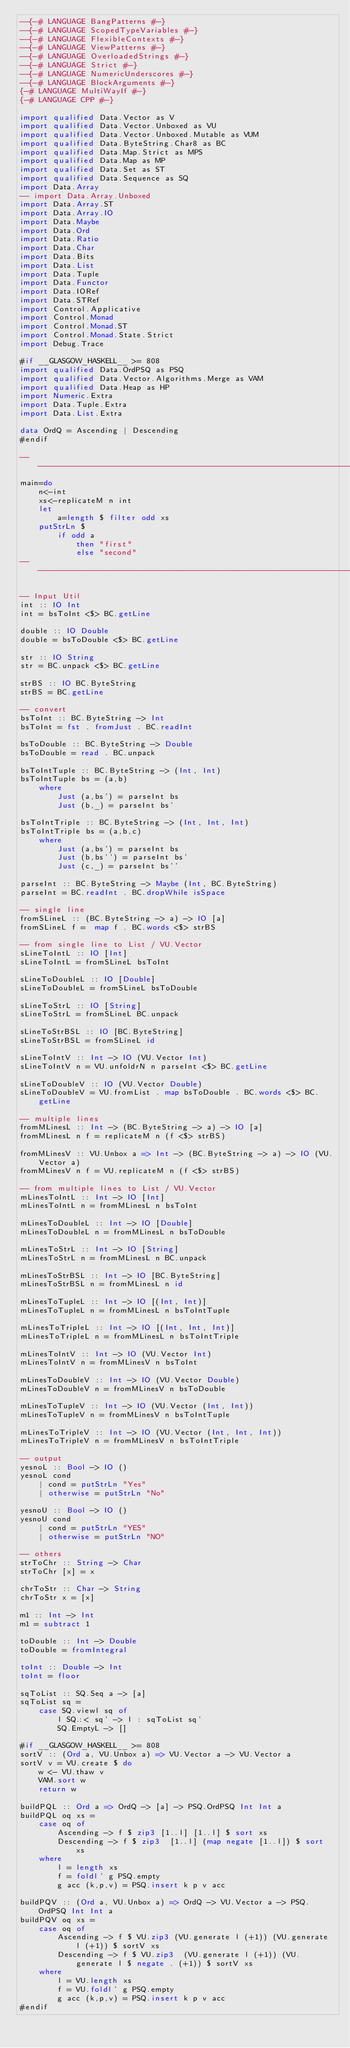<code> <loc_0><loc_0><loc_500><loc_500><_Haskell_>--{-# LANGUAGE BangPatterns #-}
--{-# LANGUAGE ScopedTypeVariables #-}
--{-# LANGUAGE FlexibleContexts #-}
--{-# LANGUAGE ViewPatterns #-}
--{-# LANGUAGE OverloadedStrings #-}
--{-# LANGUAGE Strict #-}
--{-# LANGUAGE NumericUnderscores #-}
--{-# LANGUAGE BlockArguments #-}
{-# LANGUAGE MultiWayIf #-}
{-# LANGUAGE CPP #-}

import qualified Data.Vector as V
import qualified Data.Vector.Unboxed as VU
import qualified Data.Vector.Unboxed.Mutable as VUM
import qualified Data.ByteString.Char8 as BC
import qualified Data.Map.Strict as MPS
import qualified Data.Map as MP
import qualified Data.Set as ST
import qualified Data.Sequence as SQ
import Data.Array
-- import Data.Array.Unboxed
import Data.Array.ST
import Data.Array.IO
import Data.Maybe
import Data.Ord
import Data.Ratio
import Data.Char
import Data.Bits
import Data.List
import Data.Tuple
import Data.Functor
import Data.IORef
import Data.STRef
import Control.Applicative
import Control.Monad
import Control.Monad.ST
import Control.Monad.State.Strict
import Debug.Trace

#if __GLASGOW_HASKELL__ >= 808
import qualified Data.OrdPSQ as PSQ
import qualified Data.Vector.Algorithms.Merge as VAM
import qualified Data.Heap as HP
import Numeric.Extra
import Data.Tuple.Extra
import Data.List.Extra

data OrdQ = Ascending | Descending
#endif

---------------------------------------------------------------------------
main=do
    n<-int
    xs<-replicateM n int
    let
        a=length $ filter odd xs
    putStrLn $
        if odd a
            then "first"
            else "second"
--------------------------------------------------------------------------

-- Input Util
int :: IO Int
int = bsToInt <$> BC.getLine

double :: IO Double
double = bsToDouble <$> BC.getLine

str :: IO String
str = BC.unpack <$> BC.getLine

strBS :: IO BC.ByteString
strBS = BC.getLine

-- convert
bsToInt :: BC.ByteString -> Int
bsToInt = fst . fromJust . BC.readInt

bsToDouble :: BC.ByteString -> Double
bsToDouble = read . BC.unpack

bsToIntTuple :: BC.ByteString -> (Int, Int)
bsToIntTuple bs = (a,b)
    where
        Just (a,bs') = parseInt bs
        Just (b,_) = parseInt bs'

bsToIntTriple :: BC.ByteString -> (Int, Int, Int)
bsToIntTriple bs = (a,b,c)
    where
        Just (a,bs') = parseInt bs
        Just (b,bs'') = parseInt bs'
        Just (c,_) = parseInt bs''

parseInt :: BC.ByteString -> Maybe (Int, BC.ByteString)
parseInt = BC.readInt . BC.dropWhile isSpace

-- single line
fromSLineL :: (BC.ByteString -> a) -> IO [a]
fromSLineL f =  map f . BC.words <$> strBS

-- from single line to List / VU.Vector
sLineToIntL :: IO [Int]
sLineToIntL = fromSLineL bsToInt

sLineToDoubleL :: IO [Double]
sLineToDoubleL = fromSLineL bsToDouble

sLineToStrL :: IO [String]
sLineToStrL = fromSLineL BC.unpack

sLineToStrBSL :: IO [BC.ByteString]
sLineToStrBSL = fromSLineL id

sLineToIntV :: Int -> IO (VU.Vector Int)
sLineToIntV n = VU.unfoldrN n parseInt <$> BC.getLine

sLineToDoubleV :: IO (VU.Vector Double)
sLineToDoubleV = VU.fromList . map bsToDouble . BC.words <$> BC.getLine

-- multiple lines
fromMLinesL :: Int -> (BC.ByteString -> a) -> IO [a]
fromMLinesL n f = replicateM n (f <$> strBS)

fromMLinesV :: VU.Unbox a => Int -> (BC.ByteString -> a) -> IO (VU.Vector a)
fromMLinesV n f = VU.replicateM n (f <$> strBS)

-- from multiple lines to List / VU.Vector
mLinesToIntL :: Int -> IO [Int]
mLinesToIntL n = fromMLinesL n bsToInt

mLinesToDoubleL :: Int -> IO [Double]
mLinesToDoubleL n = fromMLinesL n bsToDouble

mLinesToStrL :: Int -> IO [String]
mLinesToStrL n = fromMLinesL n BC.unpack

mLinesToStrBSL :: Int -> IO [BC.ByteString]
mLinesToStrBSL n = fromMLinesL n id

mLinesToTupleL :: Int -> IO [(Int, Int)]
mLinesToTupleL n = fromMLinesL n bsToIntTuple

mLinesToTripleL :: Int -> IO [(Int, Int, Int)]
mLinesToTripleL n = fromMLinesL n bsToIntTriple

mLinesToIntV :: Int -> IO (VU.Vector Int)
mLinesToIntV n = fromMLinesV n bsToInt

mLinesToDoubleV :: Int -> IO (VU.Vector Double)
mLinesToDoubleV n = fromMLinesV n bsToDouble

mLinesToTupleV :: Int -> IO (VU.Vector (Int, Int))
mLinesToTupleV n = fromMLinesV n bsToIntTuple

mLinesToTripleV :: Int -> IO (VU.Vector (Int, Int, Int))
mLinesToTripleV n = fromMLinesV n bsToIntTriple

-- output
yesnoL :: Bool -> IO ()
yesnoL cond
    | cond = putStrLn "Yes"
    | otherwise = putStrLn "No"

yesnoU :: Bool -> IO ()
yesnoU cond
    | cond = putStrLn "YES"
    | otherwise = putStrLn "NO"

-- others
strToChr :: String -> Char
strToChr [x] = x

chrToStr :: Char -> String
chrToStr x = [x]

m1 :: Int -> Int
m1 = subtract 1

toDouble :: Int -> Double
toDouble = fromIntegral

toInt :: Double -> Int
toInt = floor

sqToList :: SQ.Seq a -> [a]
sqToList sq =
    case SQ.viewl sq of
        l SQ.:< sq' -> l : sqToList sq'
        SQ.EmptyL -> []

#if __GLASGOW_HASKELL__ >= 808
sortV :: (Ord a, VU.Unbox a) => VU.Vector a -> VU.Vector a
sortV v = VU.create $ do
    w <- VU.thaw v
    VAM.sort w
    return w

buildPQL :: Ord a => OrdQ -> [a] -> PSQ.OrdPSQ Int Int a
buildPQL oq xs =
    case oq of
        Ascending -> f $ zip3 [1..l] [1..l] $ sort xs
        Descending -> f $ zip3  [1..l] (map negate [1..l]) $ sort xs
    where
        l = length xs
        f = foldl' g PSQ.empty
        g acc (k,p,v) = PSQ.insert k p v acc

buildPQV :: (Ord a, VU.Unbox a) => OrdQ -> VU.Vector a -> PSQ.OrdPSQ Int Int a
buildPQV oq xs =
    case oq of
        Ascending -> f $ VU.zip3 (VU.generate l (+1)) (VU.generate l (+1)) $ sortV xs
        Descending -> f $ VU.zip3  (VU.generate l (+1)) (VU.generate l $ negate . (+1)) $ sortV xs
    where
        l = VU.length xs
        f = VU.foldl' g PSQ.empty
        g acc (k,p,v) = PSQ.insert k p v acc
#endif</code> 